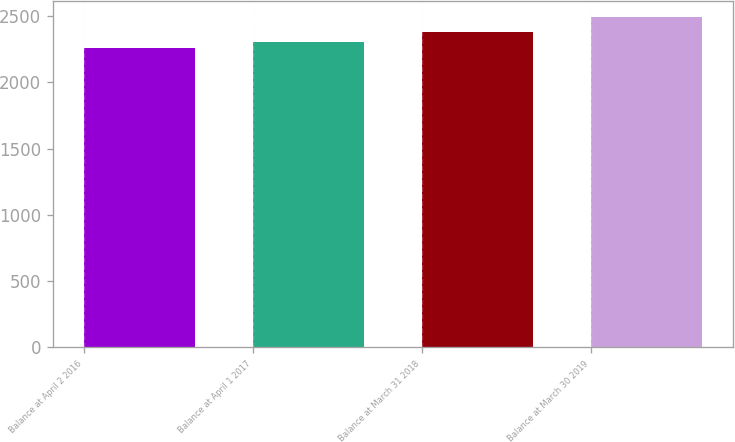Convert chart to OTSL. <chart><loc_0><loc_0><loc_500><loc_500><bar_chart><fcel>Balance at April 2 2016<fcel>Balance at April 1 2017<fcel>Balance at March 31 2018<fcel>Balance at March 30 2019<nl><fcel>2257.5<fcel>2308.8<fcel>2383.4<fcel>2493.8<nl></chart> 